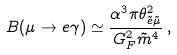Convert formula to latex. <formula><loc_0><loc_0><loc_500><loc_500>B ( \mu \to e \gamma ) \simeq \frac { \alpha ^ { 3 } \pi \theta _ { { \tilde { e } } { \tilde { \mu } } } ^ { 2 } } { G _ { F } ^ { 2 } { \tilde { m } } ^ { 4 } } \, ,</formula> 